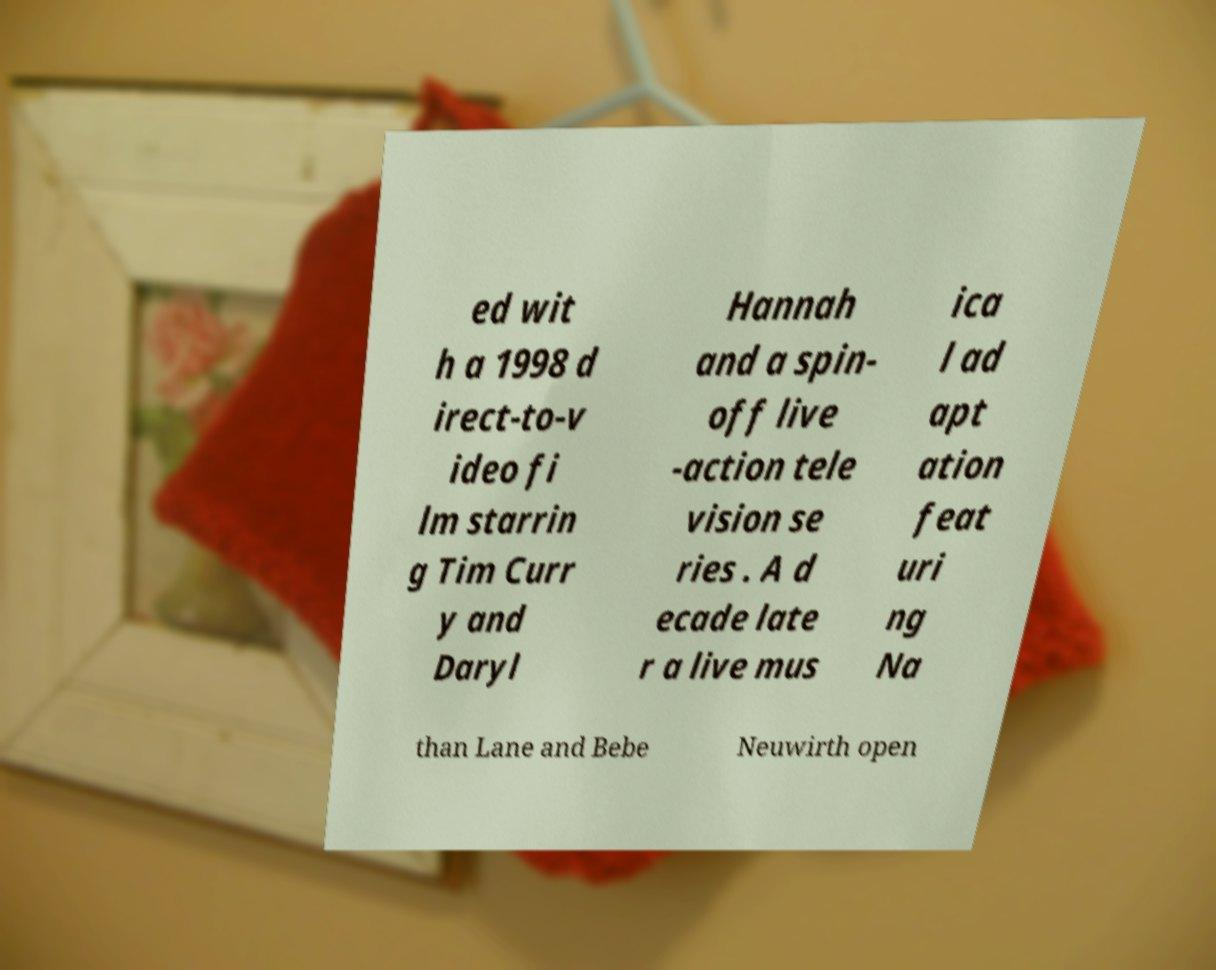Please read and relay the text visible in this image. What does it say? ed wit h a 1998 d irect-to-v ideo fi lm starrin g Tim Curr y and Daryl Hannah and a spin- off live -action tele vision se ries . A d ecade late r a live mus ica l ad apt ation feat uri ng Na than Lane and Bebe Neuwirth open 